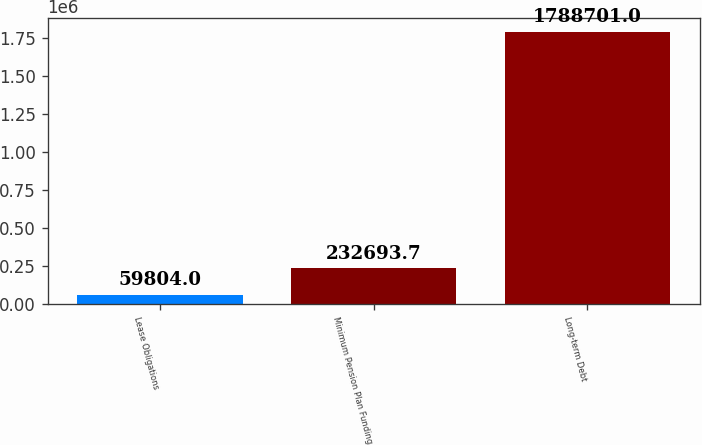<chart> <loc_0><loc_0><loc_500><loc_500><bar_chart><fcel>Lease Obligations<fcel>Minimum Pension Plan Funding<fcel>Long-term Debt<nl><fcel>59804<fcel>232694<fcel>1.7887e+06<nl></chart> 